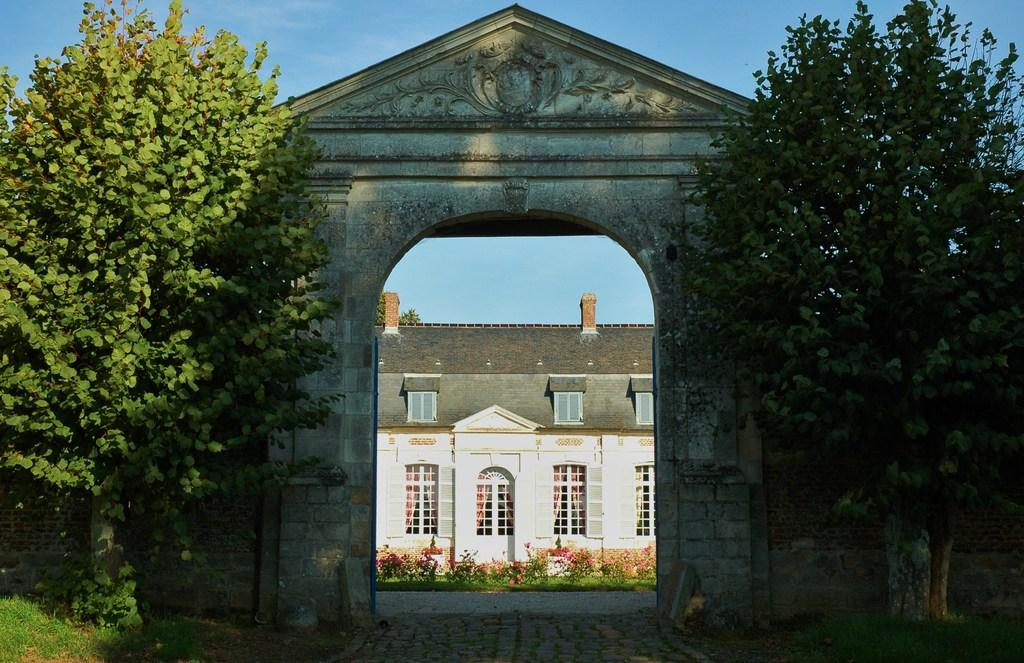What structure is the main focus of the image? There is an arch in the image. What type of vegetation is present on both sides of the arch? There are trees on both sides of the arch. What can be seen behind the arch and trees in the image? There is a building visible behind the arch and trees. What type of carpenter is working on the arch in the image? There is no carpenter present in the image, and the arch appears to be a completed structure. What year is depicted in the image? The image does not contain any information about a specific year. 